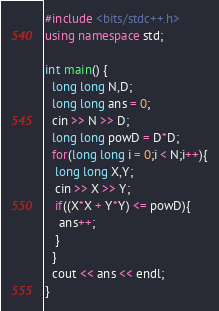Convert code to text. <code><loc_0><loc_0><loc_500><loc_500><_C++_>#include <bits/stdc++.h>
using namespace std;
 
int main() {
  long long N,D;
  long long ans = 0;
  cin >> N >> D;
  long long powD = D*D;
  for(long long i = 0;i < N;i++){
   long long X,Y;
   cin >> X >> Y;
   if((X*X + Y*Y) <= powD){
    ans++;
   }    
  }
  cout << ans << endl;
} </code> 